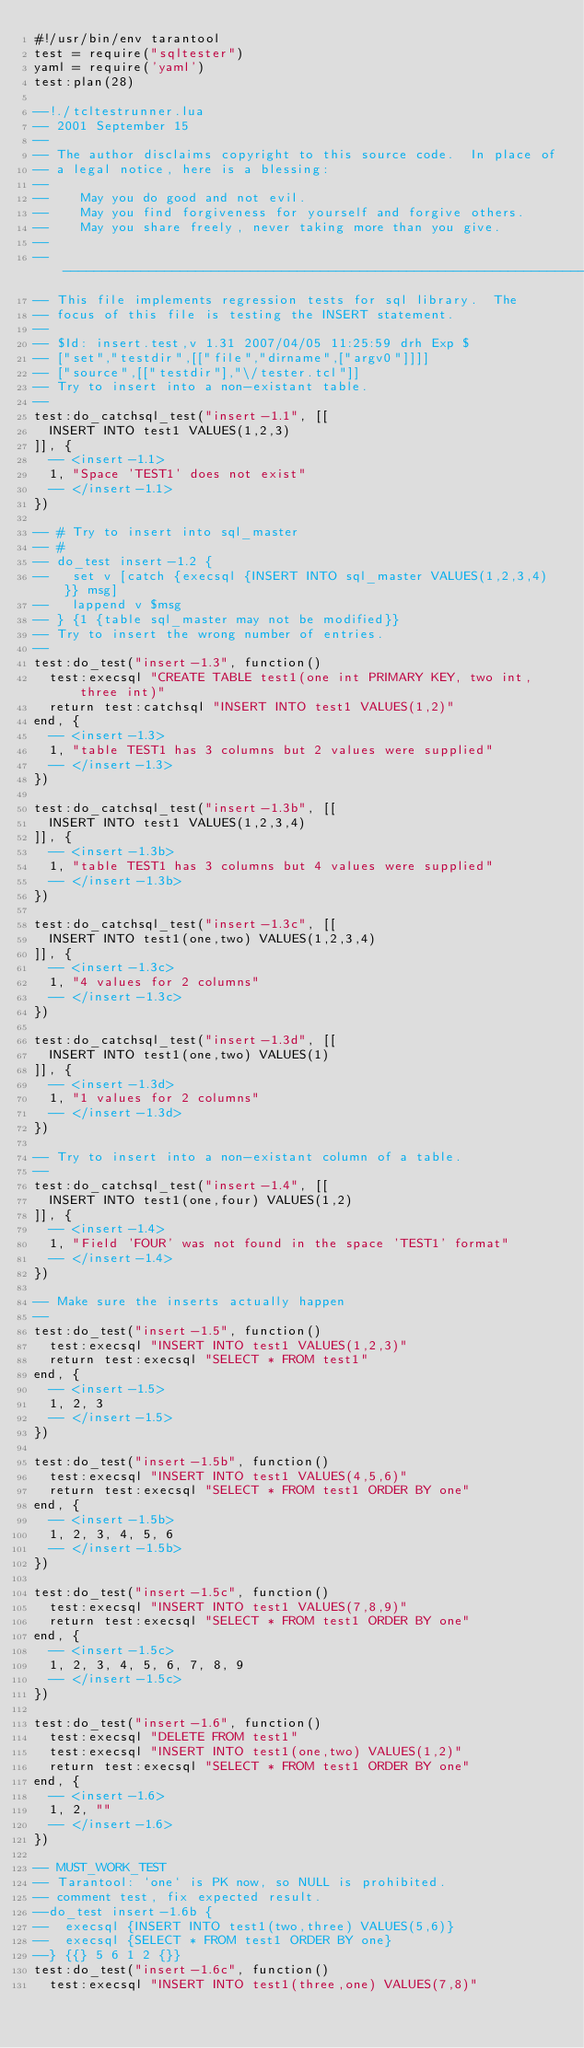<code> <loc_0><loc_0><loc_500><loc_500><_Lua_>#!/usr/bin/env tarantool
test = require("sqltester")
yaml = require('yaml')
test:plan(28)

--!./tcltestrunner.lua
-- 2001 September 15
--
-- The author disclaims copyright to this source code.  In place of
-- a legal notice, here is a blessing:
--
--    May you do good and not evil.
--    May you find forgiveness for yourself and forgive others.
--    May you share freely, never taking more than you give.
--
-------------------------------------------------------------------------
-- This file implements regression tests for sql library.  The
-- focus of this file is testing the INSERT statement.
--
-- $Id: insert.test,v 1.31 2007/04/05 11:25:59 drh Exp $
-- ["set","testdir",[["file","dirname",["argv0"]]]]
-- ["source",[["testdir"],"\/tester.tcl"]]
-- Try to insert into a non-existant table.
--
test:do_catchsql_test("insert-1.1", [[
  INSERT INTO test1 VALUES(1,2,3)
]], {
  -- <insert-1.1>
  1, "Space 'TEST1' does not exist"
  -- </insert-1.1>
})

-- # Try to insert into sql_master
-- #
-- do_test insert-1.2 {
--   set v [catch {execsql {INSERT INTO sql_master VALUES(1,2,3,4)}} msg]
--   lappend v $msg
-- } {1 {table sql_master may not be modified}}
-- Try to insert the wrong number of entries.
--
test:do_test("insert-1.3", function()
  test:execsql "CREATE TABLE test1(one int PRIMARY KEY, two int, three int)"
  return test:catchsql "INSERT INTO test1 VALUES(1,2)"
end, {
  -- <insert-1.3>
  1, "table TEST1 has 3 columns but 2 values were supplied"
  -- </insert-1.3>
})

test:do_catchsql_test("insert-1.3b", [[
  INSERT INTO test1 VALUES(1,2,3,4)
]], {
  -- <insert-1.3b>
  1, "table TEST1 has 3 columns but 4 values were supplied"
  -- </insert-1.3b>
})

test:do_catchsql_test("insert-1.3c", [[
  INSERT INTO test1(one,two) VALUES(1,2,3,4)
]], {
  -- <insert-1.3c>
  1, "4 values for 2 columns"
  -- </insert-1.3c>
})

test:do_catchsql_test("insert-1.3d", [[
  INSERT INTO test1(one,two) VALUES(1)
]], {
  -- <insert-1.3d>
  1, "1 values for 2 columns"
  -- </insert-1.3d>
})

-- Try to insert into a non-existant column of a table.
--
test:do_catchsql_test("insert-1.4", [[
  INSERT INTO test1(one,four) VALUES(1,2)
]], {
  -- <insert-1.4>
  1, "Field 'FOUR' was not found in the space 'TEST1' format"
  -- </insert-1.4>
})

-- Make sure the inserts actually happen
--
test:do_test("insert-1.5", function()
  test:execsql "INSERT INTO test1 VALUES(1,2,3)"
  return test:execsql "SELECT * FROM test1"
end, {
  -- <insert-1.5>
  1, 2, 3
  -- </insert-1.5>
})

test:do_test("insert-1.5b", function()
  test:execsql "INSERT INTO test1 VALUES(4,5,6)"
  return test:execsql "SELECT * FROM test1 ORDER BY one"
end, {
  -- <insert-1.5b>
  1, 2, 3, 4, 5, 6
  -- </insert-1.5b>
})

test:do_test("insert-1.5c", function()
  test:execsql "INSERT INTO test1 VALUES(7,8,9)"
  return test:execsql "SELECT * FROM test1 ORDER BY one"
end, {
  -- <insert-1.5c>
  1, 2, 3, 4, 5, 6, 7, 8, 9
  -- </insert-1.5c>
})

test:do_test("insert-1.6", function()
  test:execsql "DELETE FROM test1"
  test:execsql "INSERT INTO test1(one,two) VALUES(1,2)"
  return test:execsql "SELECT * FROM test1 ORDER BY one"
end, {
  -- <insert-1.6>
  1, 2, ""
  -- </insert-1.6>
})

-- MUST_WORK_TEST
-- Tarantool: `one` is PK now, so NULL is prohibited.
-- comment test, fix expected result.
--do_test insert-1.6b {
--  execsql {INSERT INTO test1(two,three) VALUES(5,6)}
--  execsql {SELECT * FROM test1 ORDER BY one}
--} {{} 5 6 1 2 {}}
test:do_test("insert-1.6c", function()
  test:execsql "INSERT INTO test1(three,one) VALUES(7,8)"</code> 